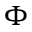Convert formula to latex. <formula><loc_0><loc_0><loc_500><loc_500>\Phi</formula> 